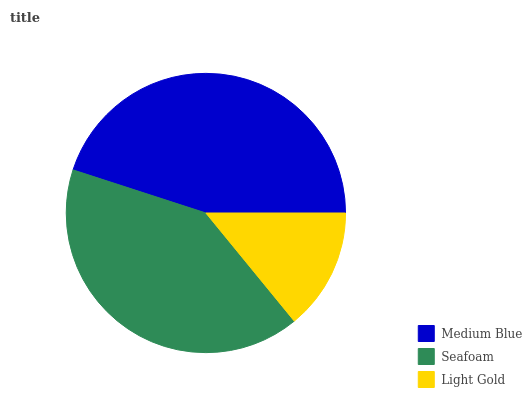Is Light Gold the minimum?
Answer yes or no. Yes. Is Medium Blue the maximum?
Answer yes or no. Yes. Is Seafoam the minimum?
Answer yes or no. No. Is Seafoam the maximum?
Answer yes or no. No. Is Medium Blue greater than Seafoam?
Answer yes or no. Yes. Is Seafoam less than Medium Blue?
Answer yes or no. Yes. Is Seafoam greater than Medium Blue?
Answer yes or no. No. Is Medium Blue less than Seafoam?
Answer yes or no. No. Is Seafoam the high median?
Answer yes or no. Yes. Is Seafoam the low median?
Answer yes or no. Yes. Is Medium Blue the high median?
Answer yes or no. No. Is Medium Blue the low median?
Answer yes or no. No. 